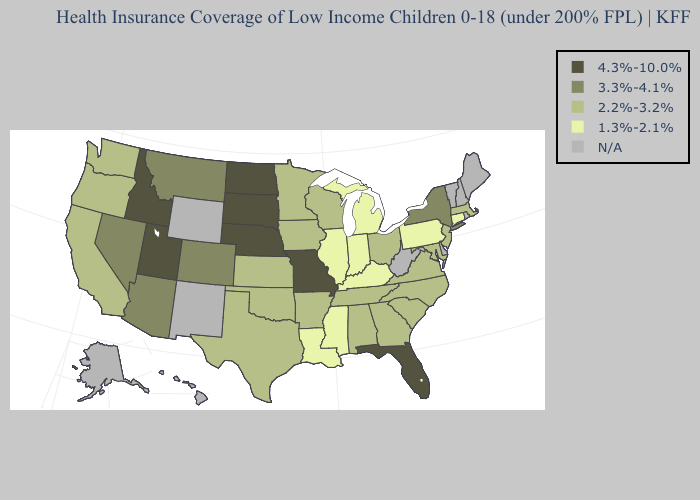Which states have the lowest value in the USA?
Answer briefly. Connecticut, Illinois, Indiana, Kentucky, Louisiana, Michigan, Mississippi, Pennsylvania. Name the states that have a value in the range 3.3%-4.1%?
Give a very brief answer. Arizona, Colorado, Montana, Nevada, New York. Does the map have missing data?
Be succinct. Yes. Among the states that border Nevada , which have the lowest value?
Concise answer only. California, Oregon. How many symbols are there in the legend?
Concise answer only. 5. What is the value of Hawaii?
Give a very brief answer. N/A. Does the map have missing data?
Concise answer only. Yes. Among the states that border Kentucky , does Ohio have the highest value?
Be succinct. No. What is the highest value in the USA?
Give a very brief answer. 4.3%-10.0%. Name the states that have a value in the range N/A?
Write a very short answer. Alaska, Delaware, Hawaii, Maine, New Hampshire, New Mexico, Rhode Island, Vermont, West Virginia, Wyoming. Does the map have missing data?
Quick response, please. Yes. What is the highest value in states that border New Jersey?
Give a very brief answer. 3.3%-4.1%. 